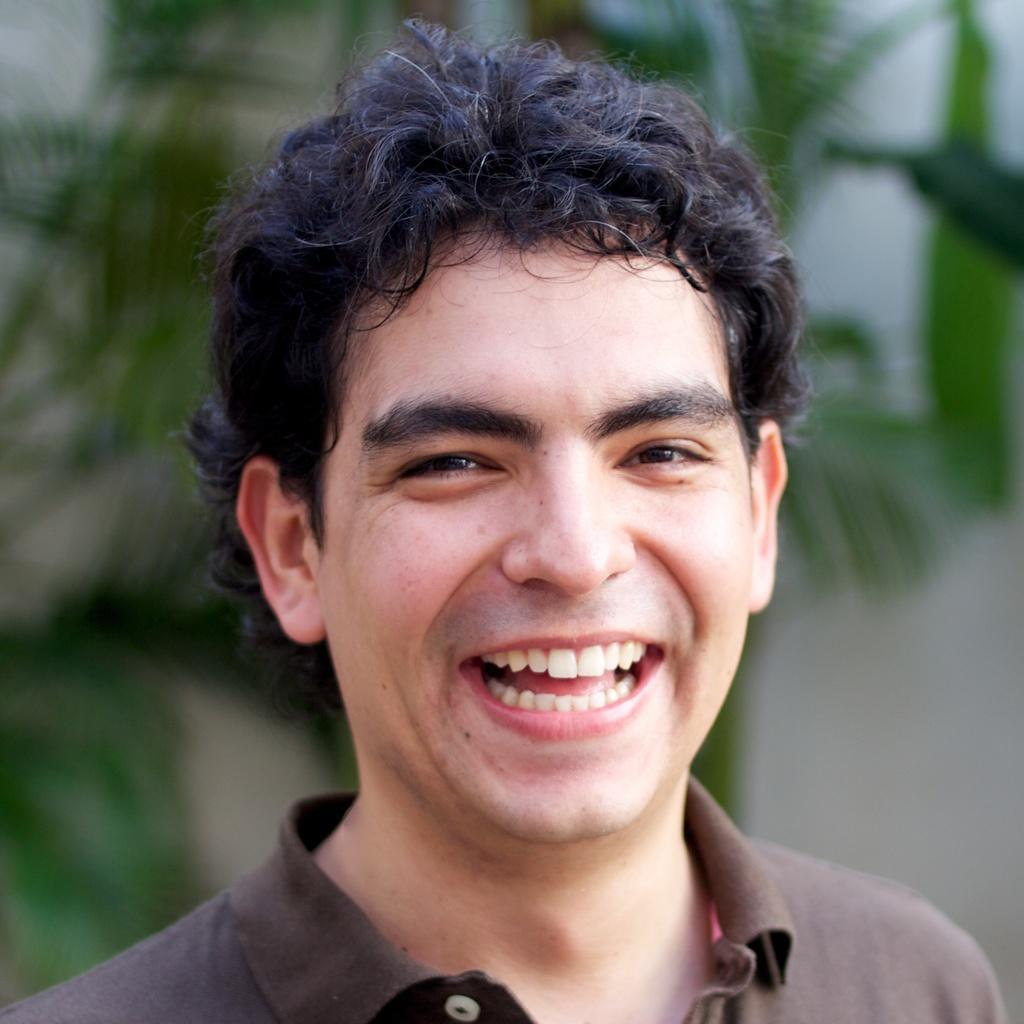Please provide a concise description of this image. In this image in front there is a person wearing a smile on his face. Behind him there are trees. 